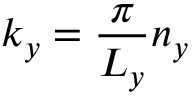Convert formula to latex. <formula><loc_0><loc_0><loc_500><loc_500>k _ { y } = \frac { \pi } { L _ { y } } n _ { y }</formula> 